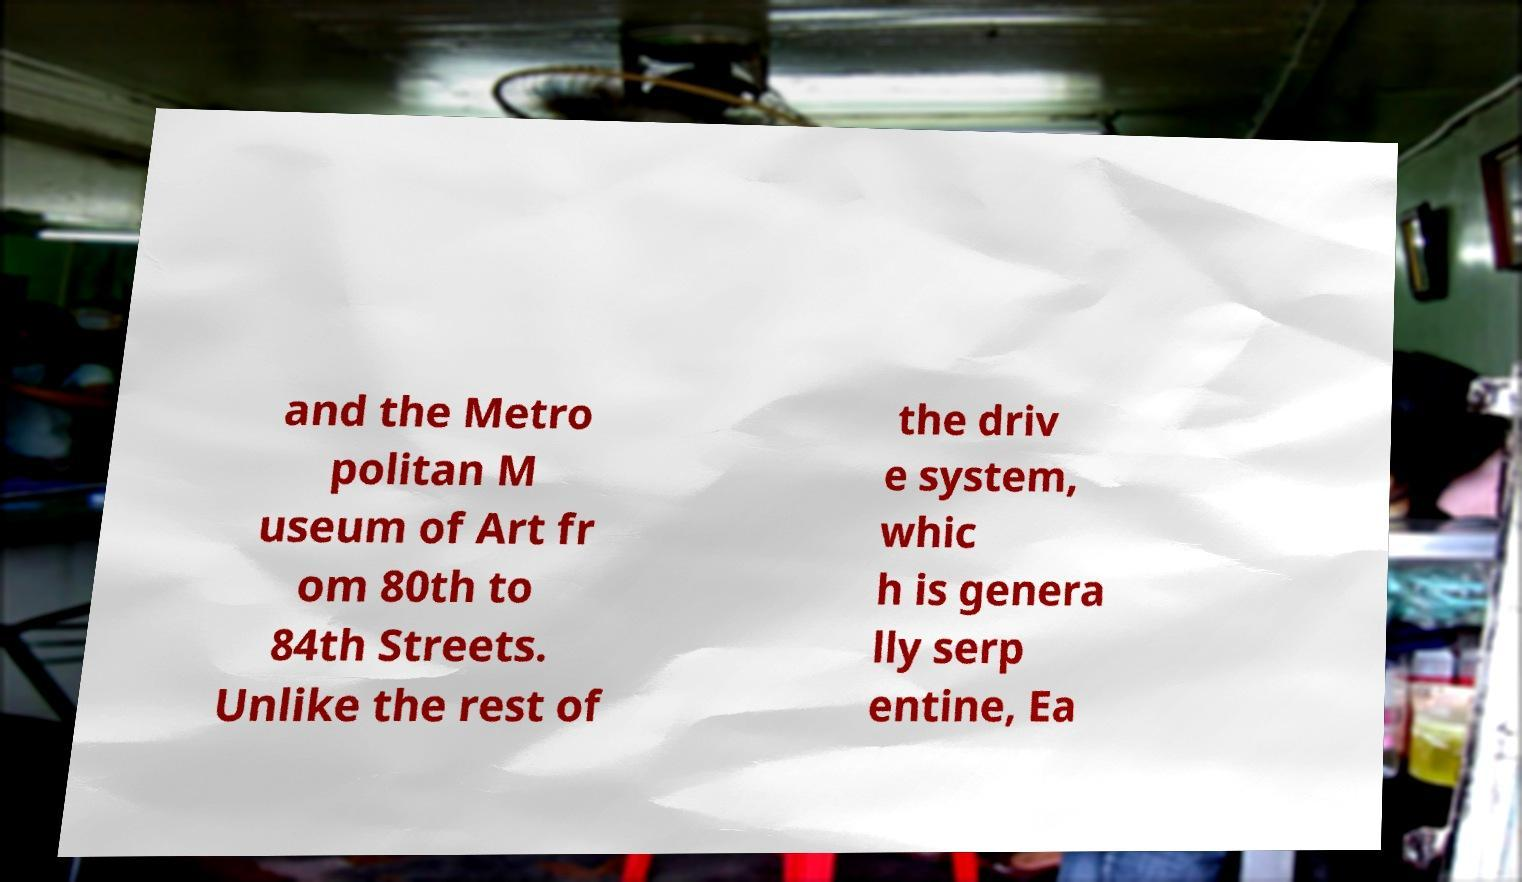What messages or text are displayed in this image? I need them in a readable, typed format. and the Metro politan M useum of Art fr om 80th to 84th Streets. Unlike the rest of the driv e system, whic h is genera lly serp entine, Ea 